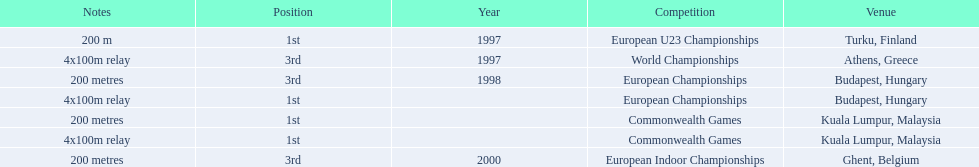How many total years did golding compete? 3. 